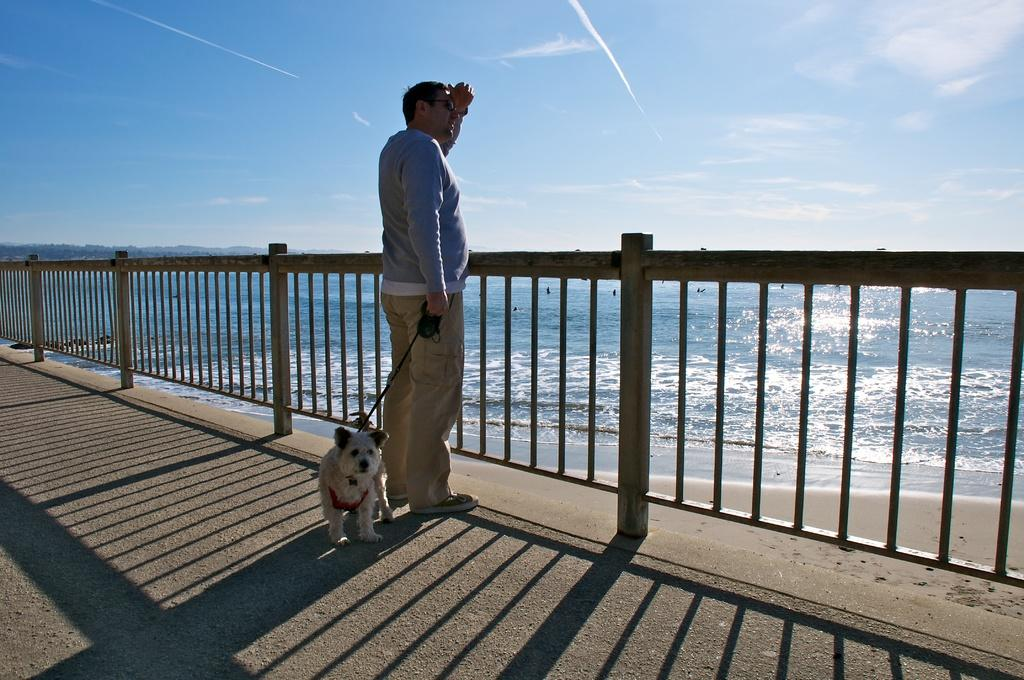Who is present in the image? There is a man in the image. Does the man have any companions in the image? Yes, the man has a pet in the image. Where are the man and his pet located in the image? They are standing near a railing in the image. What can be seen in the background of the image? They are watching through the beach in the background. What type of balloon can be seen bursting in the image? There is no balloon present in the image, let alone one that is bursting. 